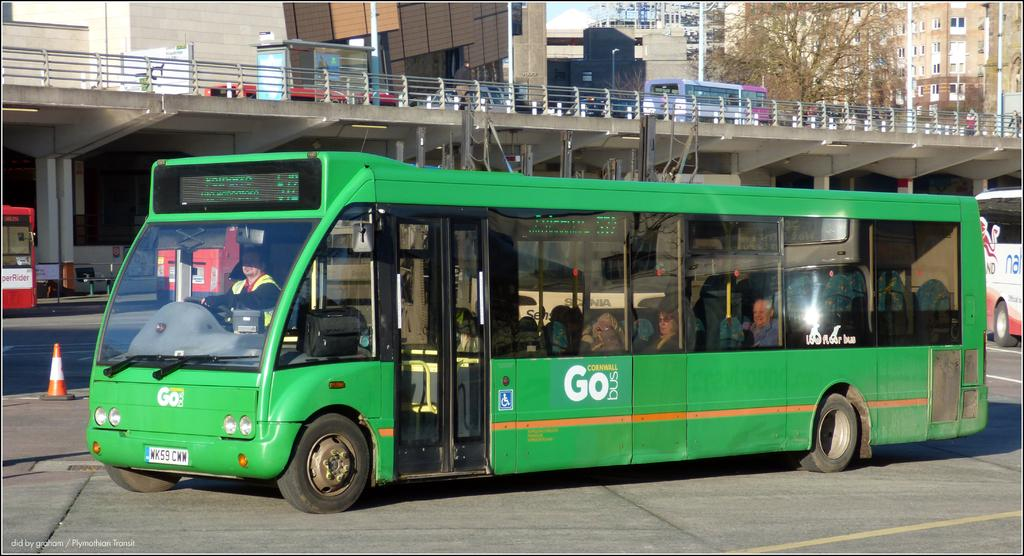<image>
Provide a brief description of the given image. The green bus is a Cornwall Go bus. 